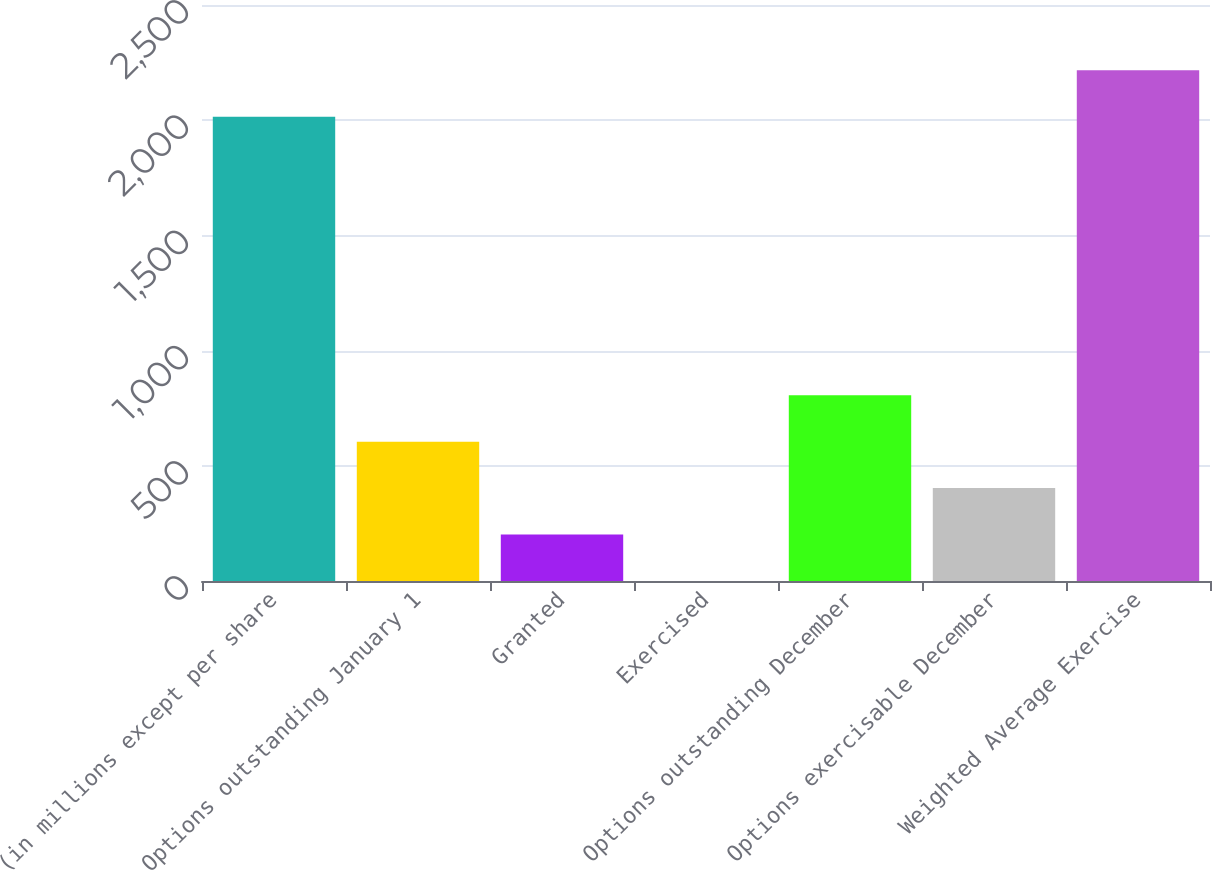Convert chart to OTSL. <chart><loc_0><loc_0><loc_500><loc_500><bar_chart><fcel>(in millions except per share<fcel>Options outstanding January 1<fcel>Granted<fcel>Exercised<fcel>Options outstanding December<fcel>Options exercisable December<fcel>Weighted Average Exercise<nl><fcel>2015<fcel>604.85<fcel>201.95<fcel>0.5<fcel>806.3<fcel>403.4<fcel>2216.45<nl></chart> 